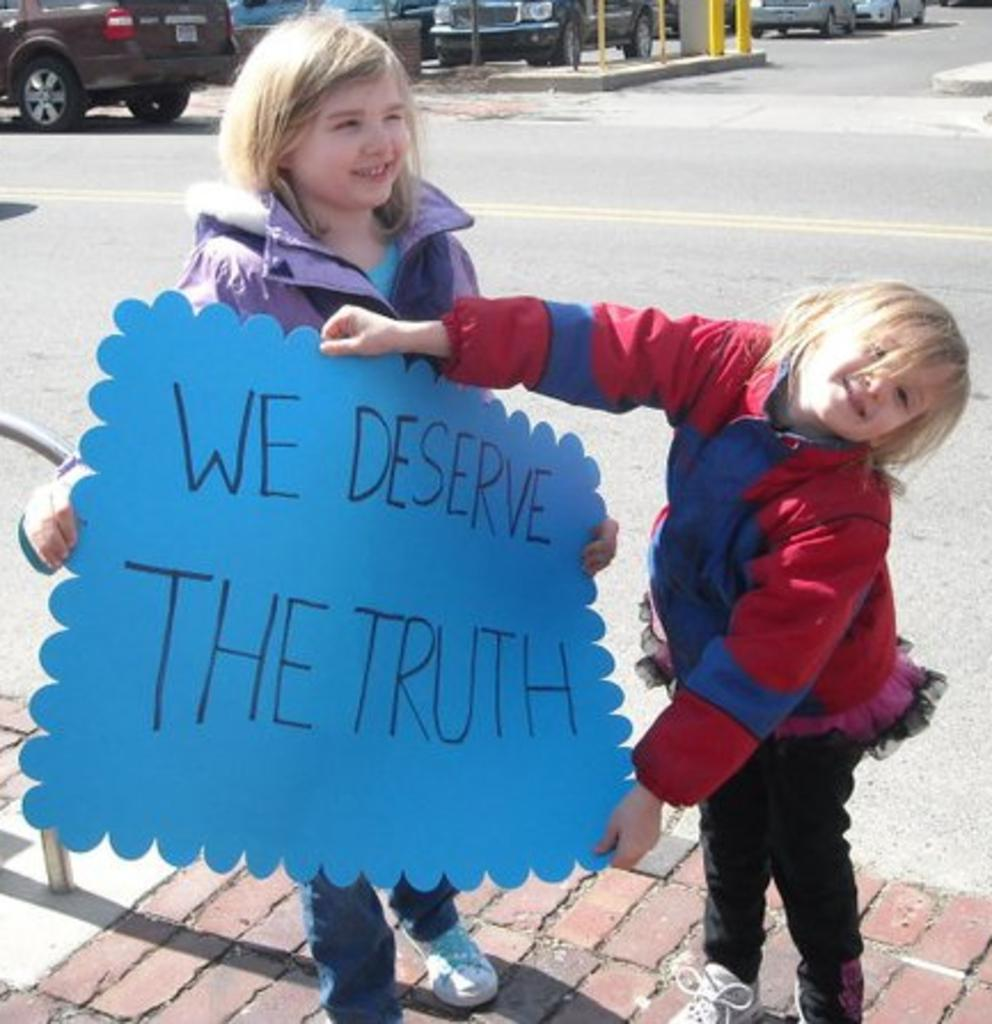What are the girls in the image holding? The girls are holding a placard in the image. What can be read on the placard? The placard has some text on it. What is visible in the background of the image? There is a road visible in the image. What else can be seen on the road? There are vehicles present in the image. What type of snow can be seen falling on the girls in the image? There is no snow present in the image; it is not mentioned in the provided facts. 